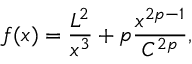Convert formula to latex. <formula><loc_0><loc_0><loc_500><loc_500>f ( x ) = \frac { L ^ { 2 } } { x ^ { 3 } } + p \frac { x ^ { 2 p - 1 } } { C ^ { 2 p } } ,</formula> 